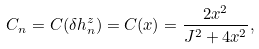<formula> <loc_0><loc_0><loc_500><loc_500>C _ { n } = C ( \delta h _ { n } ^ { z } ) = C ( x ) = \frac { 2 x ^ { 2 } } { J ^ { 2 } + 4 x ^ { 2 } } ,</formula> 